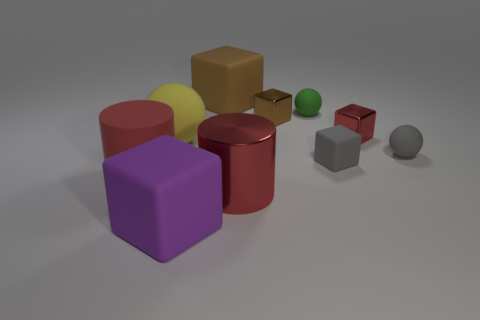Subtract all yellow spheres. How many spheres are left? 2 Subtract all brown cubes. How many cubes are left? 3 Subtract all balls. How many objects are left? 7 Subtract 2 cylinders. How many cylinders are left? 0 Subtract all purple balls. Subtract all green cylinders. How many balls are left? 3 Subtract all brown balls. How many gray blocks are left? 1 Subtract all large balls. Subtract all gray matte balls. How many objects are left? 8 Add 5 brown rubber blocks. How many brown rubber blocks are left? 6 Add 4 big brown objects. How many big brown objects exist? 5 Subtract 0 blue cubes. How many objects are left? 10 